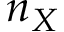<formula> <loc_0><loc_0><loc_500><loc_500>n _ { X }</formula> 